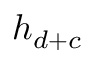Convert formula to latex. <formula><loc_0><loc_0><loc_500><loc_500>h _ { d + c }</formula> 